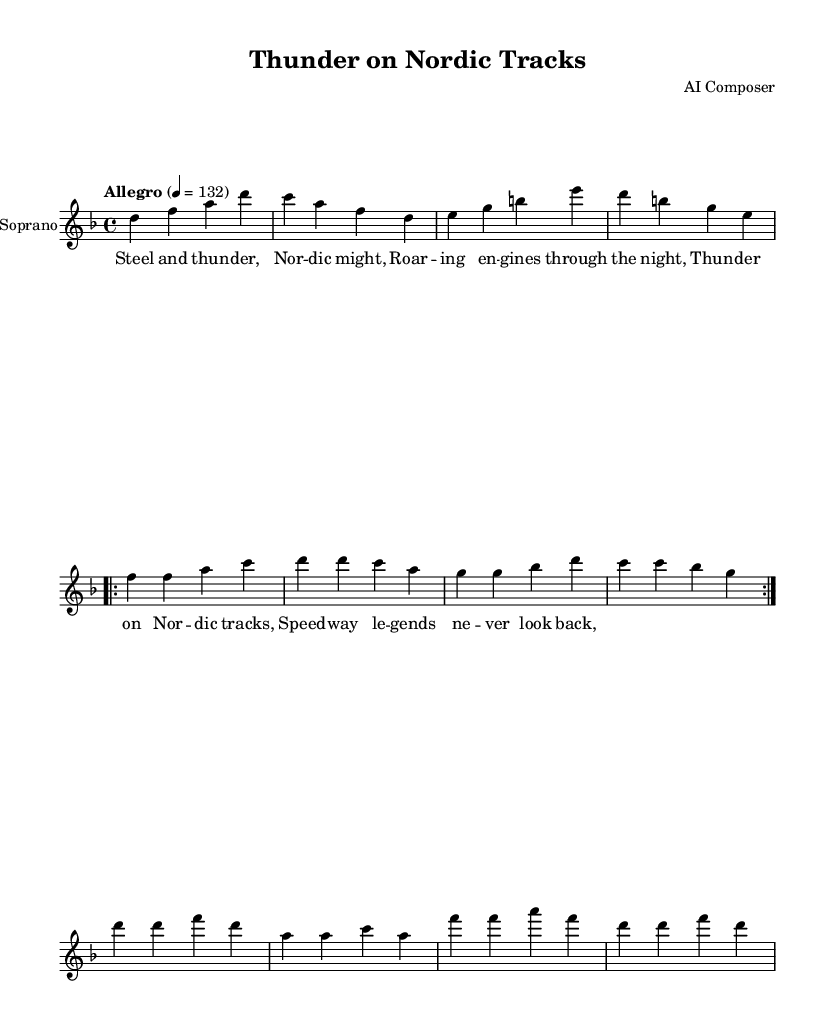What is the key signature of this music? The key signature is D minor, which includes one flat (B flat). You can identify the key signature by looking at the left side of the staff; there is a flat symbol shown before the first note.
Answer: D minor What is the time signature of this piece? The time signature is 4/4, meaning there are four beats in each measure and the quarter note receives one beat. You can see this indicated at the beginning of the music sheet, just after the key signature.
Answer: 4/4 What is the tempo marking for this piece? The tempo marking is "Allegro," and it indicates a lively pace. In the music sheet, it specifies a tempo of 132 beats per minute, which you can find written above the staff.
Answer: Allegro How many times is the verse repeated? The verse is repeated twice, which is indicated by the "repeat volta 2" instruction in the music. This notation means that the section following this instruction should be played two times.
Answer: 2 What happens in the chorus? The chorus features the lyrics "Thunder on Nordic tracks, Speedway legends never look back," capturing the central theme of the piece. You can find this part immediately after the verse section.
Answer: Thunder on Nordic tracks, Speedway legends never look back What dynamic markings are used in this piece? The dynamic marking is "dynamicUp," suggesting that the dynamics should be played with an emphasis on projection or volume. This instruction is noted at the very beginning of the soprano section.
Answer: dynamicUp 